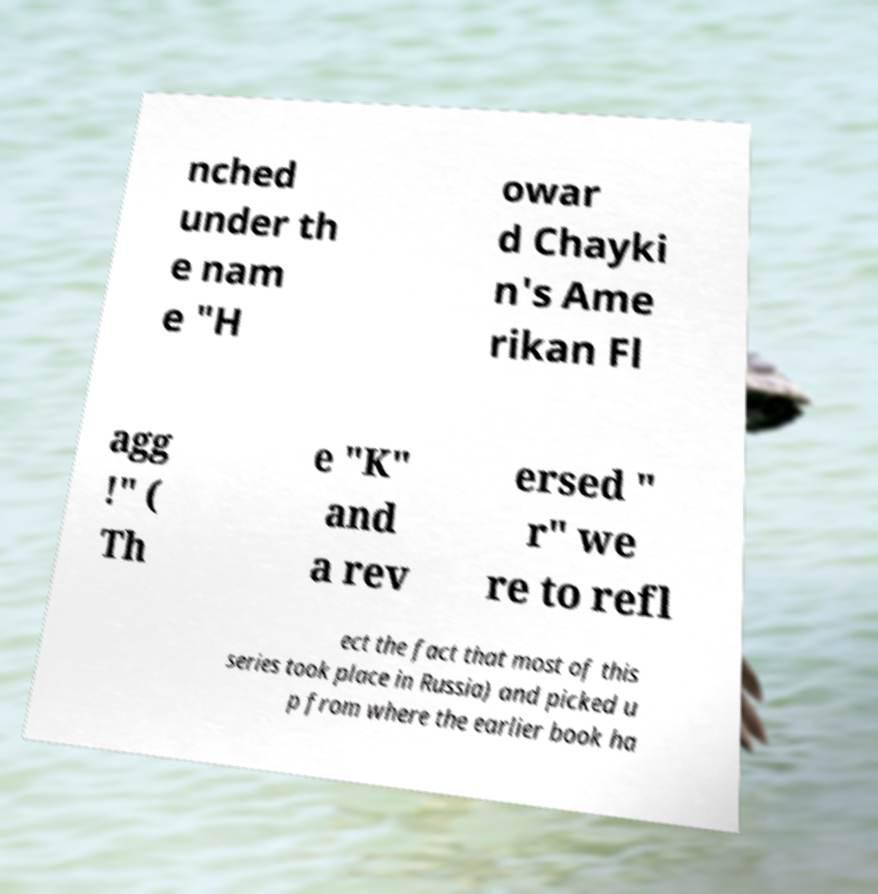Please identify and transcribe the text found in this image. nched under th e nam e "H owar d Chayki n's Ame rikan Fl agg !" ( Th e "K" and a rev ersed " r" we re to refl ect the fact that most of this series took place in Russia) and picked u p from where the earlier book ha 